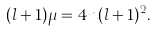<formula> <loc_0><loc_0><loc_500><loc_500>( l + 1 ) \mu = 4 n ( l + 1 ) ^ { 2 } .</formula> 